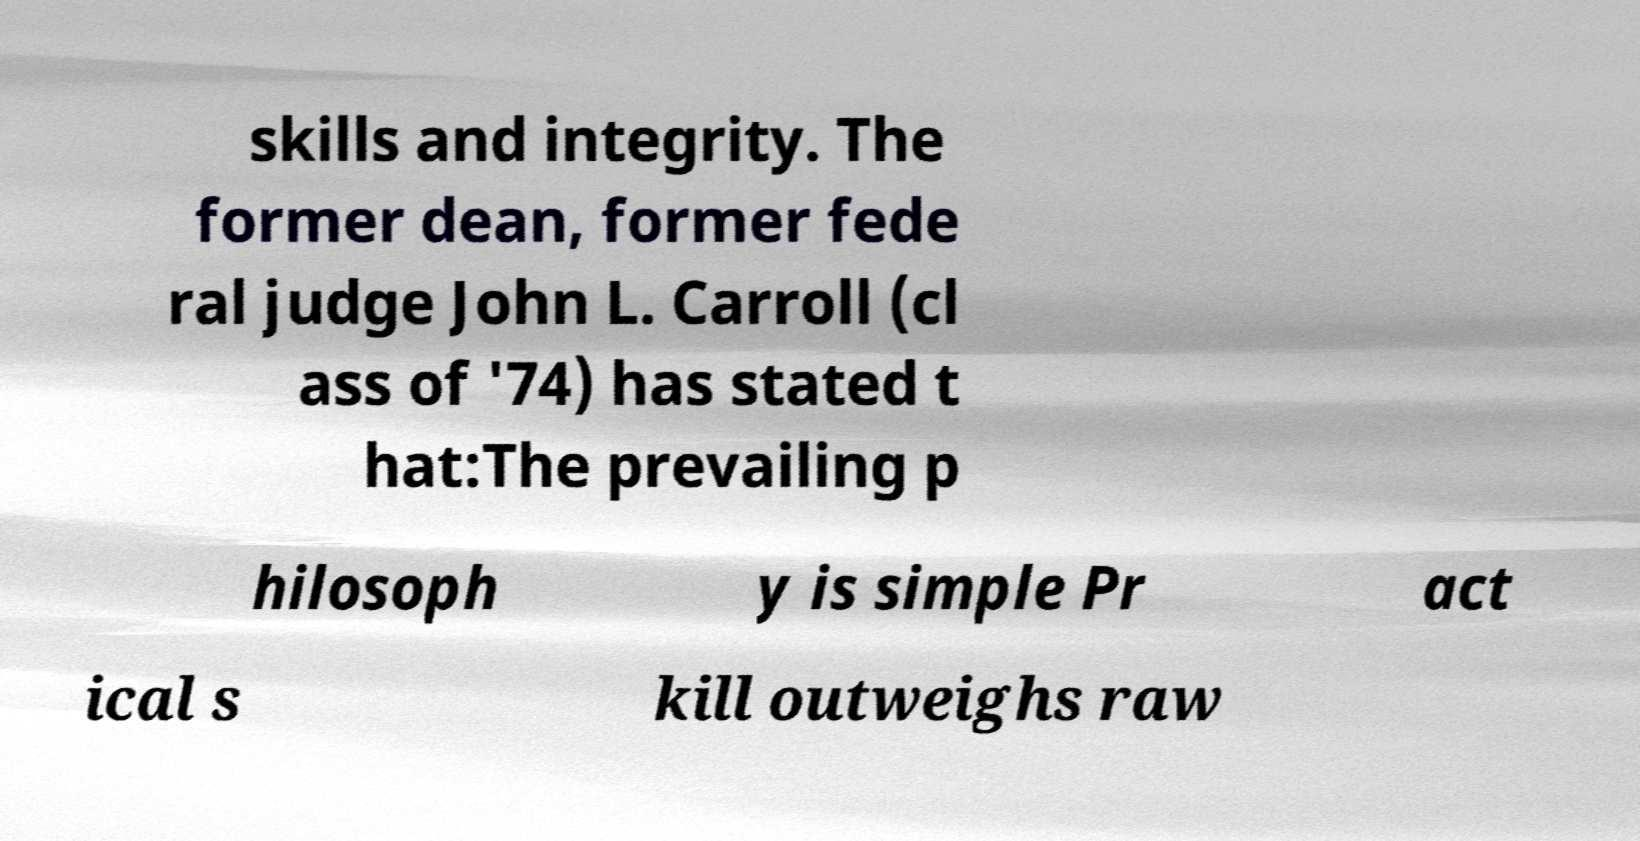Can you accurately transcribe the text from the provided image for me? skills and integrity. The former dean, former fede ral judge John L. Carroll (cl ass of '74) has stated t hat:The prevailing p hilosoph y is simple Pr act ical s kill outweighs raw 